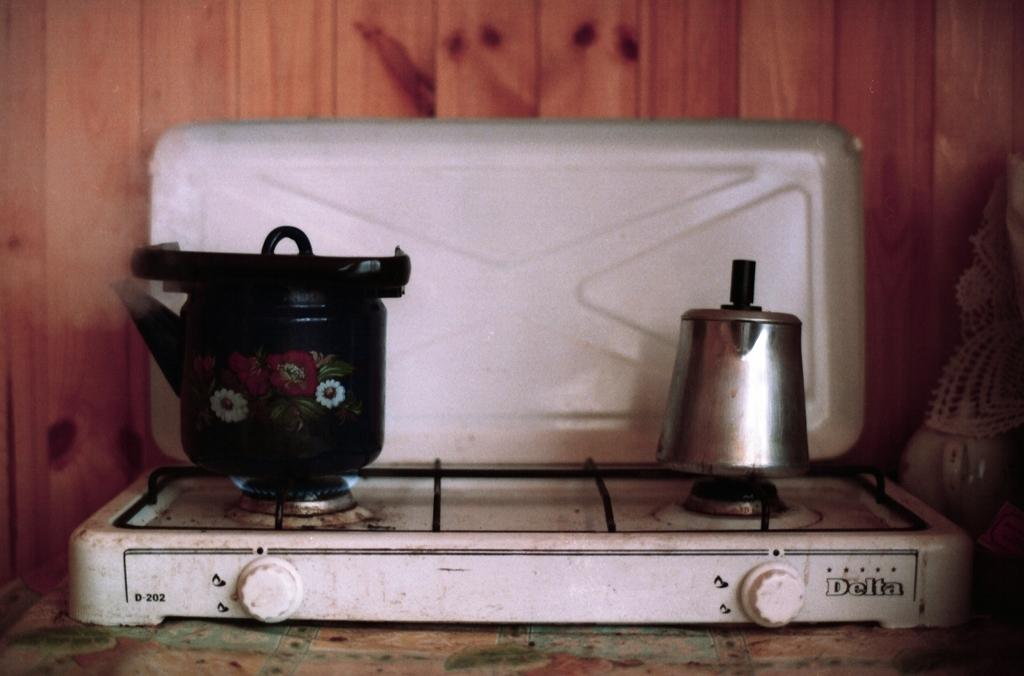Provide a one-sentence caption for the provided image. A small white hotplate is made by a company called Delta. 